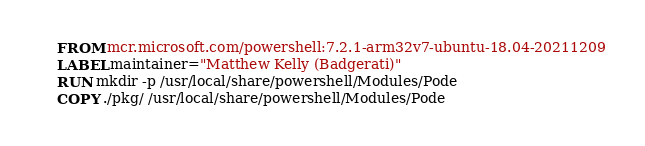<code> <loc_0><loc_0><loc_500><loc_500><_Dockerfile_>FROM mcr.microsoft.com/powershell:7.2.1-arm32v7-ubuntu-18.04-20211209
LABEL maintainer="Matthew Kelly (Badgerati)"
RUN mkdir -p /usr/local/share/powershell/Modules/Pode
COPY ./pkg/ /usr/local/share/powershell/Modules/Pode</code> 